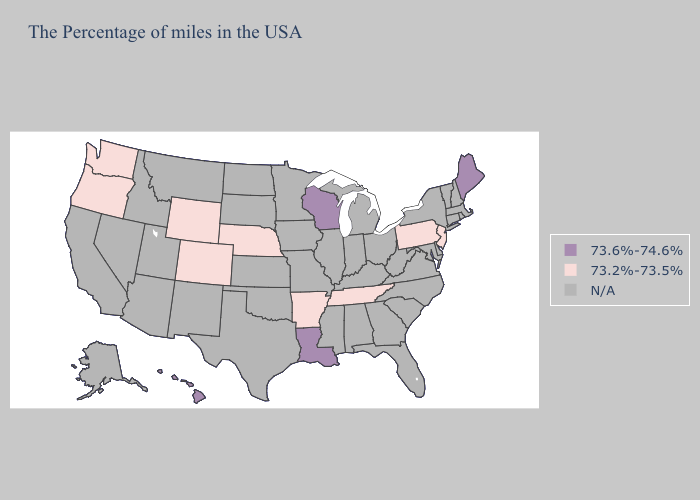Name the states that have a value in the range 73.6%-74.6%?
Answer briefly. Maine, Wisconsin, Louisiana, Hawaii. Does Washington have the highest value in the West?
Give a very brief answer. No. What is the lowest value in the Northeast?
Quick response, please. 73.2%-73.5%. Name the states that have a value in the range 73.2%-73.5%?
Write a very short answer. New Jersey, Pennsylvania, Tennessee, Arkansas, Nebraska, Wyoming, Colorado, Washington, Oregon. What is the value of Minnesota?
Quick response, please. N/A. Name the states that have a value in the range 73.2%-73.5%?
Answer briefly. New Jersey, Pennsylvania, Tennessee, Arkansas, Nebraska, Wyoming, Colorado, Washington, Oregon. What is the value of Kentucky?
Answer briefly. N/A. Does Nebraska have the highest value in the MidWest?
Quick response, please. No. What is the value of North Carolina?
Give a very brief answer. N/A. What is the value of Wyoming?
Short answer required. 73.2%-73.5%. What is the value of North Dakota?
Quick response, please. N/A. Is the legend a continuous bar?
Concise answer only. No. Does the map have missing data?
Write a very short answer. Yes. What is the value of Massachusetts?
Quick response, please. N/A. 